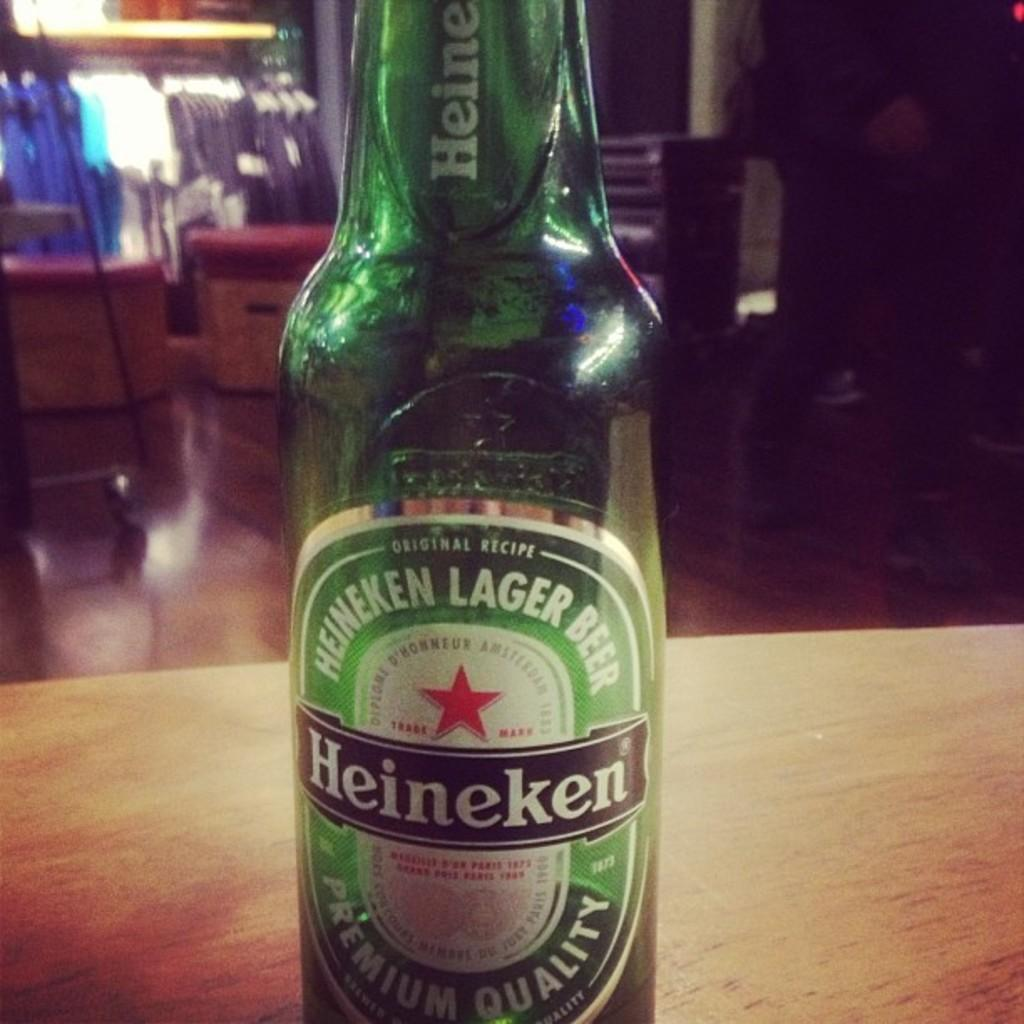<image>
Present a compact description of the photo's key features. Green bottle of Heineken sits on a wooden table. 